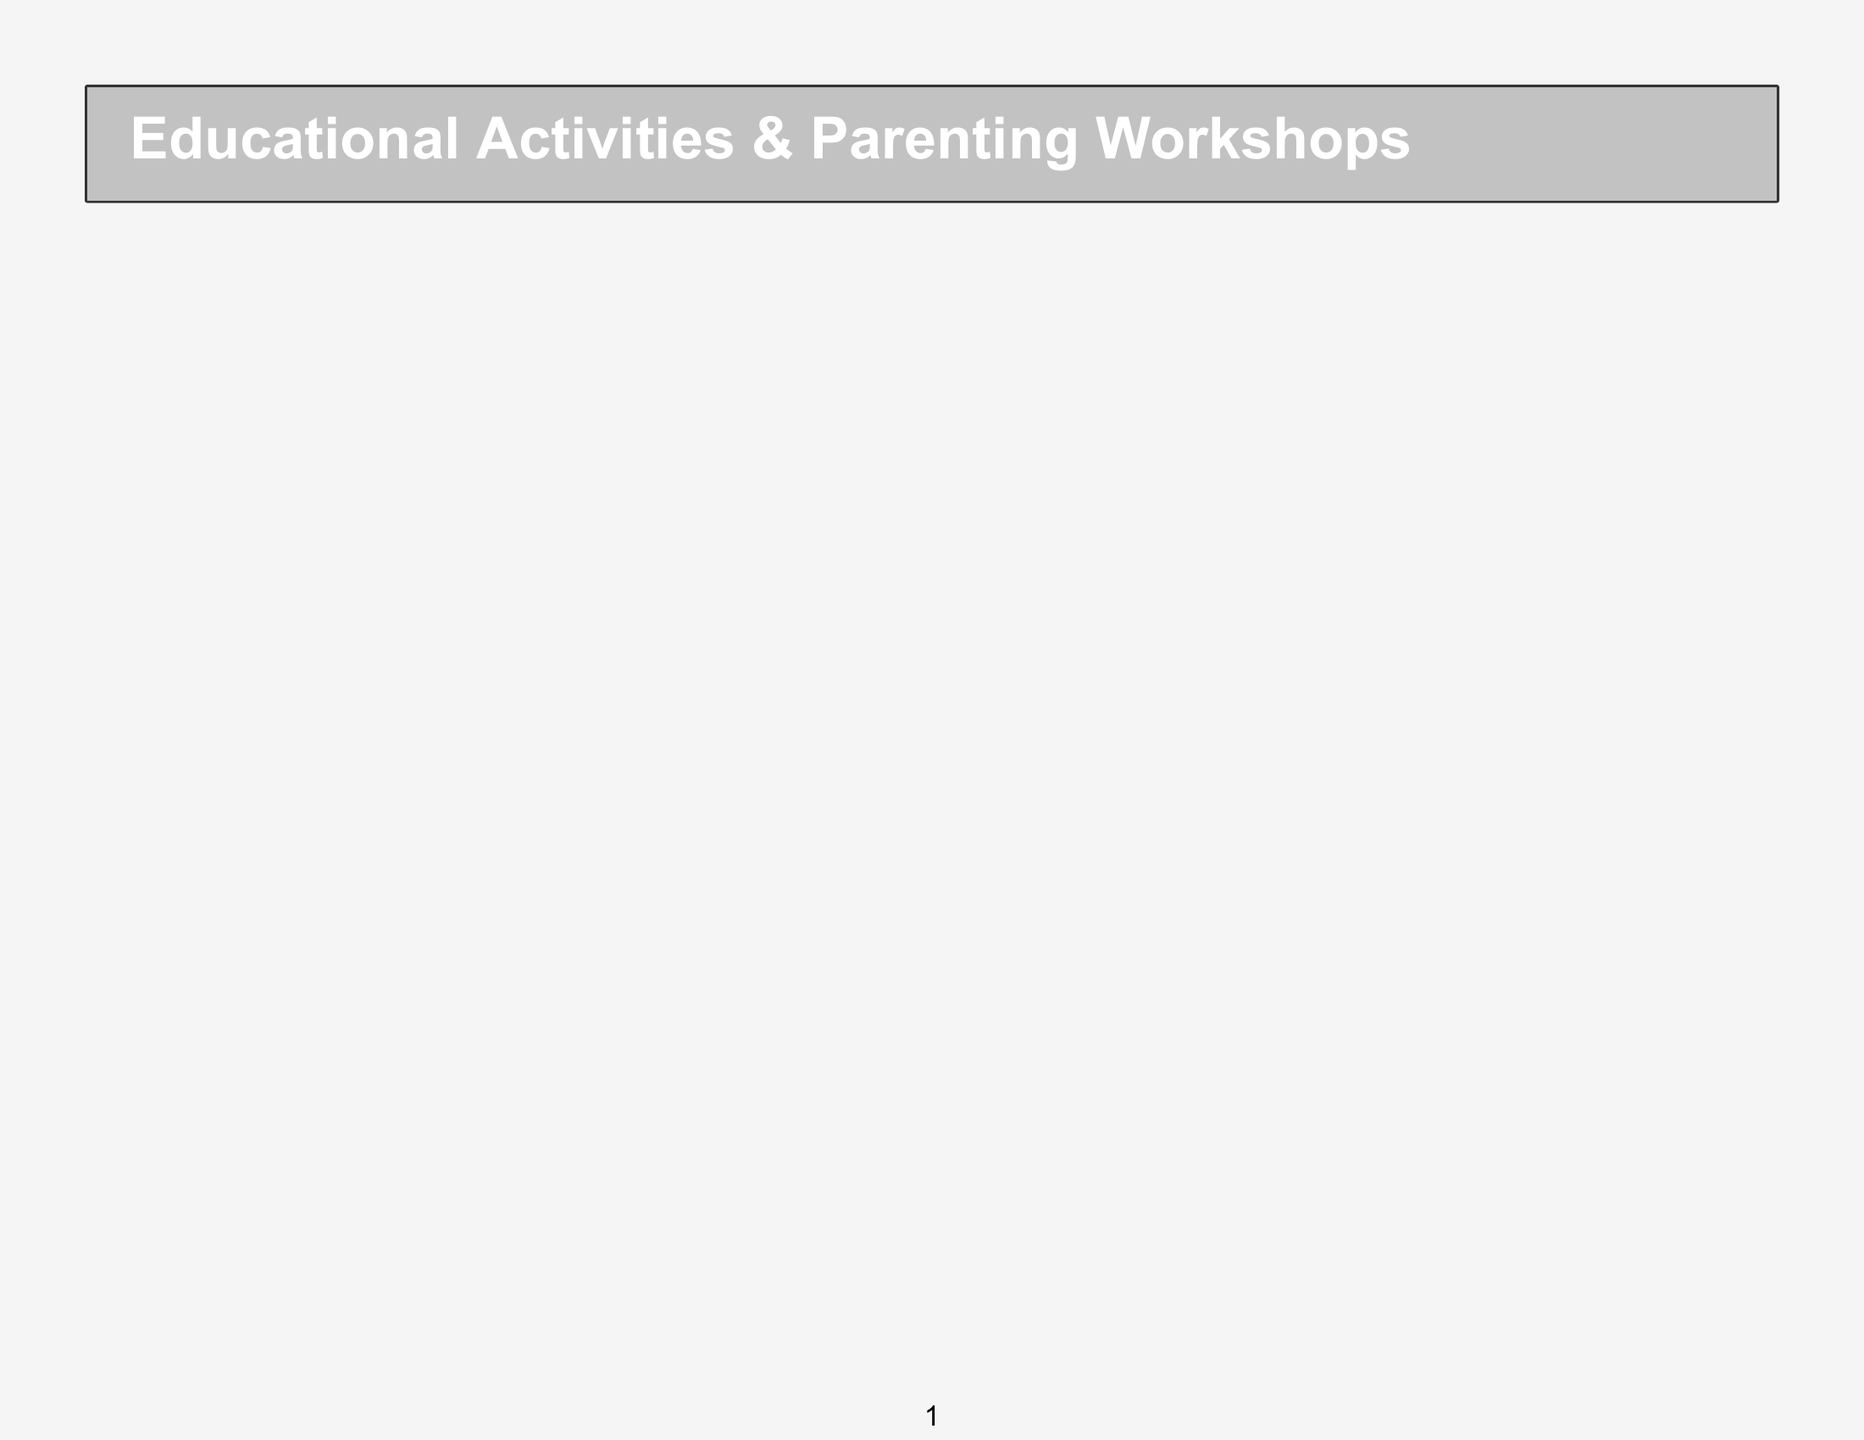What activity is scheduled on Monday at 9:00 AM? The activity scheduled on Monday at 9:00 AM is the Baby Sign Language Workshop.
Answer: Baby Sign Language Workshop Who is the speaker for the workshop on positive discipline techniques? The speaker for the workshop on positive discipline techniques is Dr. Jane Thompson.
Answer: Dr. Jane Thompson What age group is the Music and Movement Class designed for? The Music and Movement Class is designed for Toddlers (1-3 years).
Answer: Toddlers (1-3 years) How many activities are scheduled for Preschoolers on Tuesday? There are two activities scheduled for Preschoolers on Tuesday: Science Experiments for Kids and Music and Movement Class.
Answer: 2 What day and time is the workshop on nurturing your child's emotional intelligence? The workshop on nurturing your child's emotional intelligence is on Wednesday at 7:00 PM.
Answer: Wednesday 7:00 PM Which activity focuses on critical thinking for Early Elementary children? The Junior Debate Club focuses on critical thinking for Early Elementary children.
Answer: Junior Debate Club What is the color code for Early Elementary activities? The color code for Early Elementary activities is #2196F3.
Answer: #2196F3 When does the Garden Club activity take place? The Garden Club activity takes place on Friday at 11:00 AM.
Answer: Friday 11:00 AM 